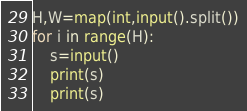Convert code to text. <code><loc_0><loc_0><loc_500><loc_500><_Python_>H,W=map(int,input().split())
for i in range(H):
    s=input()
    print(s)
    print(s)</code> 